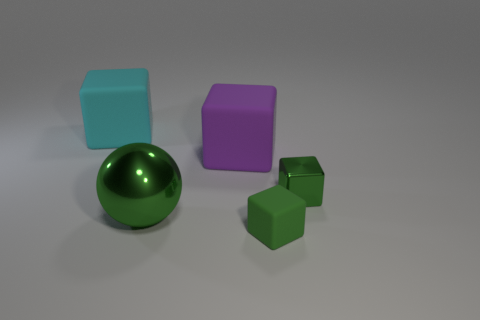Subtract all big cyan rubber blocks. How many blocks are left? 3 Add 2 small blue cylinders. How many objects exist? 7 Subtract all cyan cubes. How many cubes are left? 3 Subtract all balls. How many objects are left? 4 Subtract all cyan cylinders. How many green blocks are left? 2 Subtract 1 spheres. How many spheres are left? 0 Subtract all purple blocks. Subtract all red cylinders. How many blocks are left? 3 Subtract all big red shiny cubes. Subtract all small matte cubes. How many objects are left? 4 Add 5 metallic things. How many metallic things are left? 7 Add 1 small things. How many small things exist? 3 